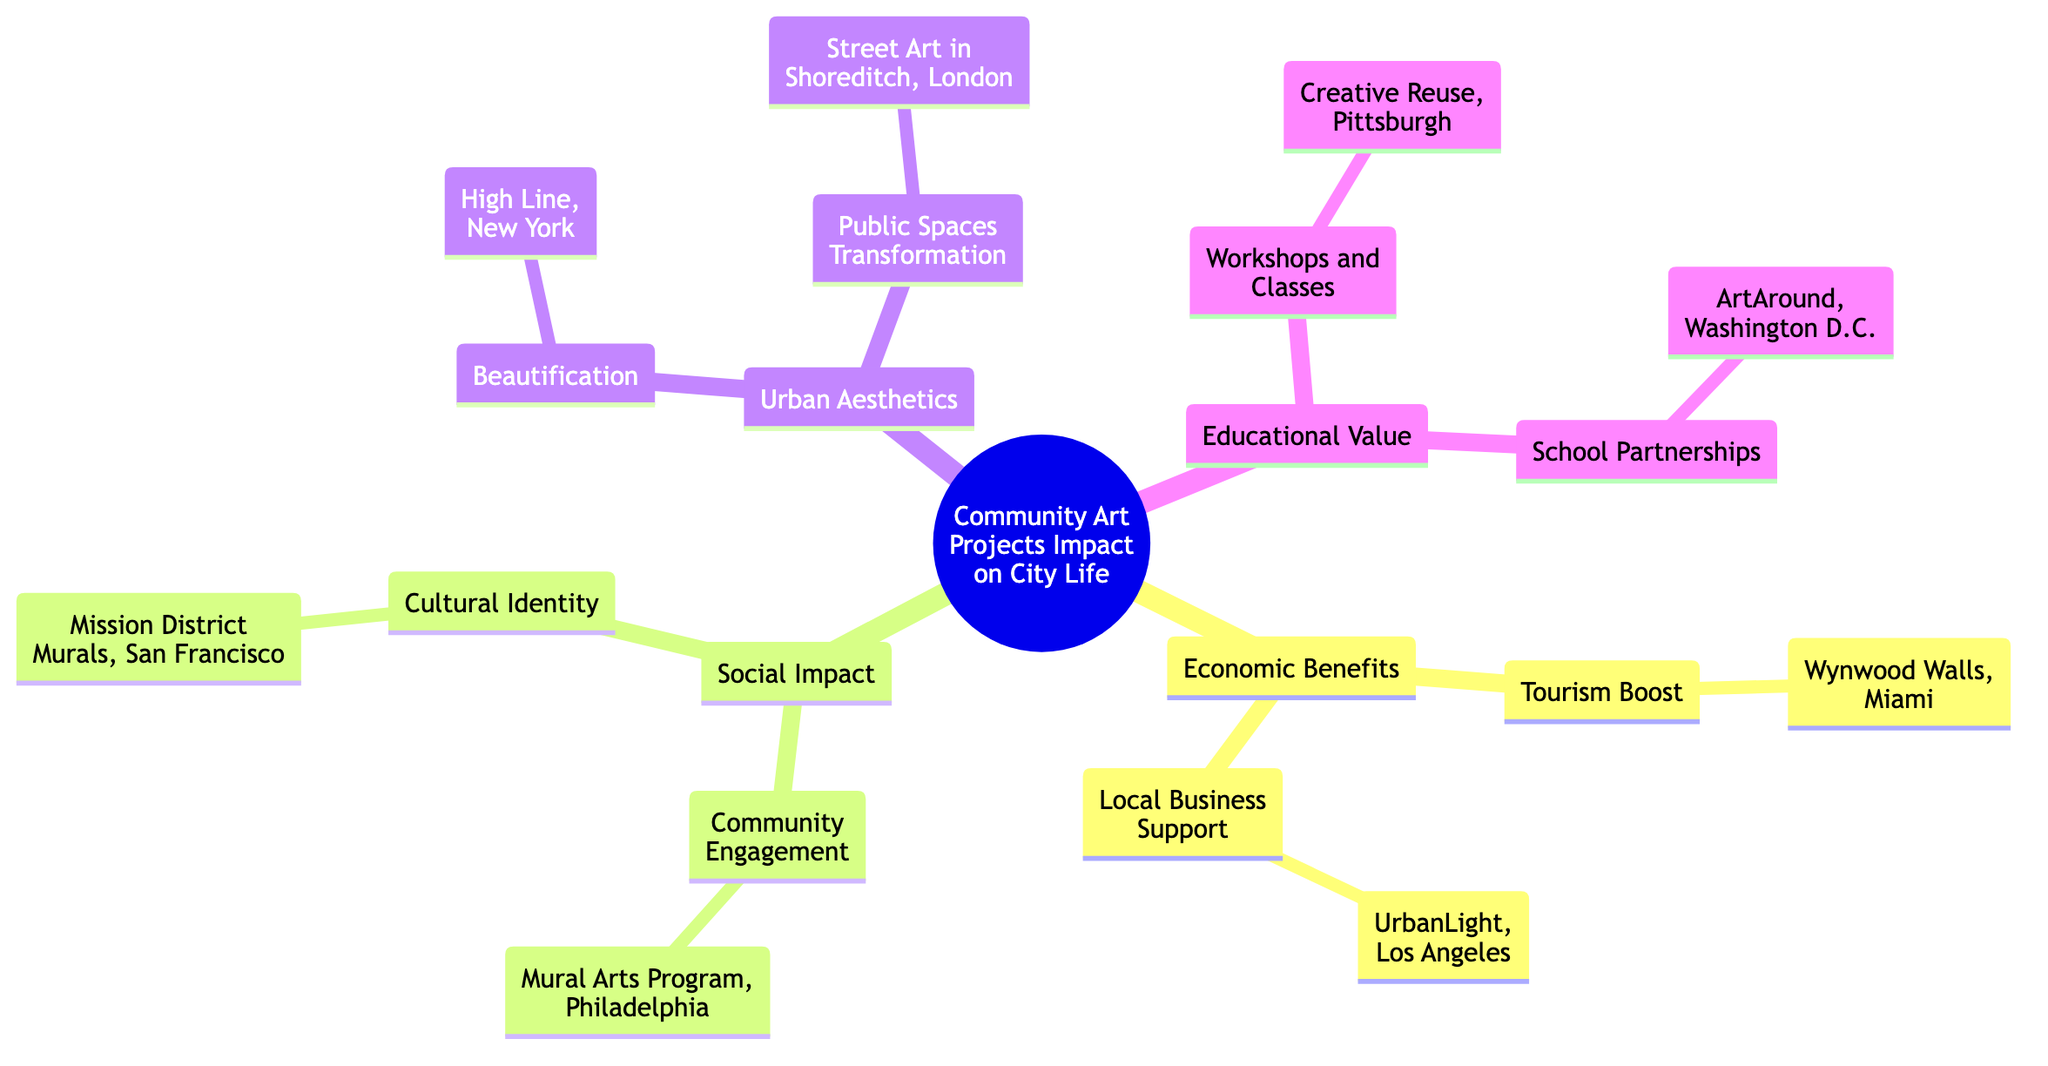What are the two subtopics under Economic Benefits? The diagram shows that under the Economic Benefits subtopic, there are two elements listed: "Tourism Boost" and "Local Business Support." Both are essential components in understanding how community art projects contribute economically to cities.
Answer: Tourism Boost, Local Business Support How many elements are listed under Urban Aesthetics? In the Urban Aesthetics section, there are two elements specified: "Beautification" and "Public Spaces Transformation." This reflects how community art influences the visual appeal and functional aspects of urban areas.
Answer: 2 Which community art project is associated with cultural identity? The diagram indicates that the "Mission District Murals, San Francisco" is the example linked to the "Cultural Identity" element, highlighting how art represents cultural values in a community.
Answer: Mission District Murals, San Francisco What is an example of a community engagement project? According to the diagram, "Mural Arts Program, Philadelphia" is provided as an example of a project that focuses on community engagement, showing how art can bring people together.
Answer: Mural Arts Program, Philadelphia Which city is associated with the beautification element? The diagram specifies "High Line, New York" as the example related to beautification, demonstrating how community art can enhance the aesthetic quality of an urban environment.
Answer: High Line, New York What is the relationship between Workshops and Classes and Educational Value? "Workshops and Classes" falls under the Educational Value section in the concept map, illustrating how community art contributes to education within society.
Answer: Educational Value How many different subtopics are identified in the diagram? The diagram presents four distinct subtopics: Economic Benefits, Social Impact, Urban Aesthetics, and Educational Value, showcasing the various dimensions of community art projects.
Answer: 4 Which project from the Educational Value subtopic is linked to school partnerships? The diagram associates "ArtAround, Washington D.C." with school partnerships, indicating its role in education through community art initiatives.
Answer: ArtAround, Washington D.C 